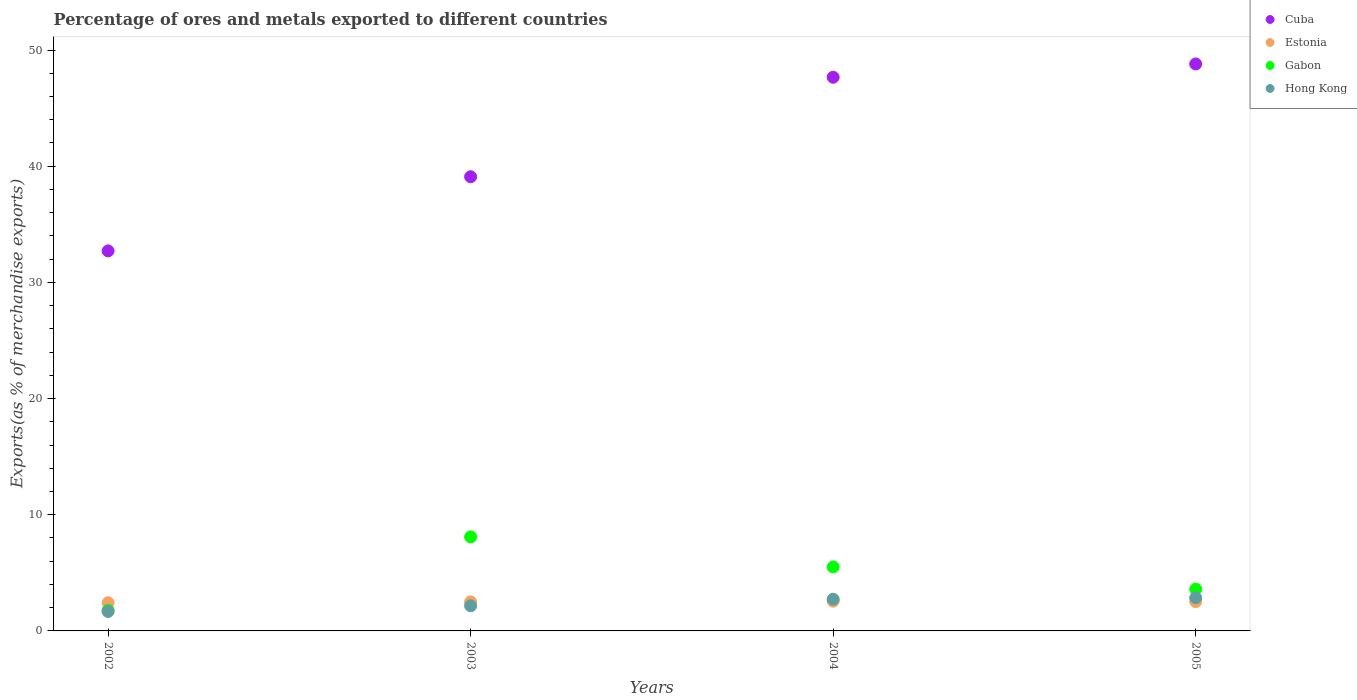How many different coloured dotlines are there?
Offer a terse response. 4. What is the percentage of exports to different countries in Gabon in 2002?
Your answer should be compact. 1.77. Across all years, what is the maximum percentage of exports to different countries in Estonia?
Provide a short and direct response. 2.56. Across all years, what is the minimum percentage of exports to different countries in Hong Kong?
Offer a very short reply. 1.67. In which year was the percentage of exports to different countries in Gabon maximum?
Provide a succinct answer. 2003. In which year was the percentage of exports to different countries in Cuba minimum?
Keep it short and to the point. 2002. What is the total percentage of exports to different countries in Cuba in the graph?
Provide a short and direct response. 168.26. What is the difference between the percentage of exports to different countries in Hong Kong in 2002 and that in 2005?
Make the answer very short. -1.18. What is the difference between the percentage of exports to different countries in Hong Kong in 2003 and the percentage of exports to different countries in Cuba in 2005?
Offer a terse response. -46.64. What is the average percentage of exports to different countries in Estonia per year?
Make the answer very short. 2.5. In the year 2004, what is the difference between the percentage of exports to different countries in Gabon and percentage of exports to different countries in Cuba?
Offer a very short reply. -42.15. In how many years, is the percentage of exports to different countries in Cuba greater than 12 %?
Give a very brief answer. 4. What is the ratio of the percentage of exports to different countries in Cuba in 2004 to that in 2005?
Make the answer very short. 0.98. Is the difference between the percentage of exports to different countries in Gabon in 2002 and 2005 greater than the difference between the percentage of exports to different countries in Cuba in 2002 and 2005?
Give a very brief answer. Yes. What is the difference between the highest and the second highest percentage of exports to different countries in Estonia?
Provide a succinct answer. 0.04. What is the difference between the highest and the lowest percentage of exports to different countries in Cuba?
Your answer should be compact. 16.09. Is the sum of the percentage of exports to different countries in Gabon in 2003 and 2004 greater than the maximum percentage of exports to different countries in Hong Kong across all years?
Keep it short and to the point. Yes. Are the values on the major ticks of Y-axis written in scientific E-notation?
Your answer should be compact. No. Does the graph contain grids?
Provide a succinct answer. No. Where does the legend appear in the graph?
Provide a succinct answer. Top right. How many legend labels are there?
Your answer should be very brief. 4. What is the title of the graph?
Your answer should be very brief. Percentage of ores and metals exported to different countries. What is the label or title of the X-axis?
Ensure brevity in your answer.  Years. What is the label or title of the Y-axis?
Ensure brevity in your answer.  Exports(as % of merchandise exports). What is the Exports(as % of merchandise exports) of Cuba in 2002?
Your answer should be compact. 32.71. What is the Exports(as % of merchandise exports) in Estonia in 2002?
Keep it short and to the point. 2.43. What is the Exports(as % of merchandise exports) of Gabon in 2002?
Offer a terse response. 1.77. What is the Exports(as % of merchandise exports) of Hong Kong in 2002?
Provide a succinct answer. 1.67. What is the Exports(as % of merchandise exports) in Cuba in 2003?
Offer a very short reply. 39.09. What is the Exports(as % of merchandise exports) of Estonia in 2003?
Keep it short and to the point. 2.5. What is the Exports(as % of merchandise exports) in Gabon in 2003?
Provide a succinct answer. 8.09. What is the Exports(as % of merchandise exports) in Hong Kong in 2003?
Provide a succinct answer. 2.16. What is the Exports(as % of merchandise exports) in Cuba in 2004?
Your answer should be compact. 47.66. What is the Exports(as % of merchandise exports) in Estonia in 2004?
Provide a succinct answer. 2.56. What is the Exports(as % of merchandise exports) of Gabon in 2004?
Ensure brevity in your answer.  5.51. What is the Exports(as % of merchandise exports) of Hong Kong in 2004?
Offer a very short reply. 2.73. What is the Exports(as % of merchandise exports) in Cuba in 2005?
Your response must be concise. 48.8. What is the Exports(as % of merchandise exports) of Estonia in 2005?
Provide a short and direct response. 2.52. What is the Exports(as % of merchandise exports) in Gabon in 2005?
Ensure brevity in your answer.  3.59. What is the Exports(as % of merchandise exports) in Hong Kong in 2005?
Your answer should be very brief. 2.85. Across all years, what is the maximum Exports(as % of merchandise exports) in Cuba?
Your response must be concise. 48.8. Across all years, what is the maximum Exports(as % of merchandise exports) in Estonia?
Offer a very short reply. 2.56. Across all years, what is the maximum Exports(as % of merchandise exports) in Gabon?
Offer a very short reply. 8.09. Across all years, what is the maximum Exports(as % of merchandise exports) of Hong Kong?
Offer a terse response. 2.85. Across all years, what is the minimum Exports(as % of merchandise exports) in Cuba?
Ensure brevity in your answer.  32.71. Across all years, what is the minimum Exports(as % of merchandise exports) in Estonia?
Your answer should be very brief. 2.43. Across all years, what is the minimum Exports(as % of merchandise exports) in Gabon?
Make the answer very short. 1.77. Across all years, what is the minimum Exports(as % of merchandise exports) in Hong Kong?
Give a very brief answer. 1.67. What is the total Exports(as % of merchandise exports) of Cuba in the graph?
Ensure brevity in your answer.  168.26. What is the total Exports(as % of merchandise exports) of Estonia in the graph?
Give a very brief answer. 10.01. What is the total Exports(as % of merchandise exports) of Gabon in the graph?
Your answer should be compact. 18.97. What is the total Exports(as % of merchandise exports) in Hong Kong in the graph?
Your answer should be compact. 9.42. What is the difference between the Exports(as % of merchandise exports) in Cuba in 2002 and that in 2003?
Offer a terse response. -6.38. What is the difference between the Exports(as % of merchandise exports) in Estonia in 2002 and that in 2003?
Make the answer very short. -0.07. What is the difference between the Exports(as % of merchandise exports) in Gabon in 2002 and that in 2003?
Make the answer very short. -6.32. What is the difference between the Exports(as % of merchandise exports) in Hong Kong in 2002 and that in 2003?
Offer a terse response. -0.49. What is the difference between the Exports(as % of merchandise exports) in Cuba in 2002 and that in 2004?
Ensure brevity in your answer.  -14.95. What is the difference between the Exports(as % of merchandise exports) in Estonia in 2002 and that in 2004?
Provide a short and direct response. -0.13. What is the difference between the Exports(as % of merchandise exports) of Gabon in 2002 and that in 2004?
Provide a short and direct response. -3.73. What is the difference between the Exports(as % of merchandise exports) of Hong Kong in 2002 and that in 2004?
Keep it short and to the point. -1.05. What is the difference between the Exports(as % of merchandise exports) in Cuba in 2002 and that in 2005?
Provide a succinct answer. -16.09. What is the difference between the Exports(as % of merchandise exports) of Estonia in 2002 and that in 2005?
Your response must be concise. -0.09. What is the difference between the Exports(as % of merchandise exports) of Gabon in 2002 and that in 2005?
Make the answer very short. -1.82. What is the difference between the Exports(as % of merchandise exports) of Hong Kong in 2002 and that in 2005?
Provide a short and direct response. -1.18. What is the difference between the Exports(as % of merchandise exports) in Cuba in 2003 and that in 2004?
Your answer should be compact. -8.56. What is the difference between the Exports(as % of merchandise exports) of Estonia in 2003 and that in 2004?
Provide a succinct answer. -0.06. What is the difference between the Exports(as % of merchandise exports) of Gabon in 2003 and that in 2004?
Keep it short and to the point. 2.59. What is the difference between the Exports(as % of merchandise exports) of Hong Kong in 2003 and that in 2004?
Give a very brief answer. -0.57. What is the difference between the Exports(as % of merchandise exports) in Cuba in 2003 and that in 2005?
Make the answer very short. -9.71. What is the difference between the Exports(as % of merchandise exports) in Estonia in 2003 and that in 2005?
Offer a terse response. -0.02. What is the difference between the Exports(as % of merchandise exports) of Gabon in 2003 and that in 2005?
Provide a short and direct response. 4.5. What is the difference between the Exports(as % of merchandise exports) in Hong Kong in 2003 and that in 2005?
Your answer should be very brief. -0.69. What is the difference between the Exports(as % of merchandise exports) in Cuba in 2004 and that in 2005?
Keep it short and to the point. -1.15. What is the difference between the Exports(as % of merchandise exports) in Estonia in 2004 and that in 2005?
Your answer should be compact. 0.04. What is the difference between the Exports(as % of merchandise exports) in Gabon in 2004 and that in 2005?
Ensure brevity in your answer.  1.92. What is the difference between the Exports(as % of merchandise exports) in Hong Kong in 2004 and that in 2005?
Offer a terse response. -0.12. What is the difference between the Exports(as % of merchandise exports) in Cuba in 2002 and the Exports(as % of merchandise exports) in Estonia in 2003?
Provide a short and direct response. 30.21. What is the difference between the Exports(as % of merchandise exports) of Cuba in 2002 and the Exports(as % of merchandise exports) of Gabon in 2003?
Your response must be concise. 24.62. What is the difference between the Exports(as % of merchandise exports) of Cuba in 2002 and the Exports(as % of merchandise exports) of Hong Kong in 2003?
Offer a very short reply. 30.55. What is the difference between the Exports(as % of merchandise exports) in Estonia in 2002 and the Exports(as % of merchandise exports) in Gabon in 2003?
Your answer should be very brief. -5.67. What is the difference between the Exports(as % of merchandise exports) in Estonia in 2002 and the Exports(as % of merchandise exports) in Hong Kong in 2003?
Keep it short and to the point. 0.27. What is the difference between the Exports(as % of merchandise exports) in Gabon in 2002 and the Exports(as % of merchandise exports) in Hong Kong in 2003?
Keep it short and to the point. -0.39. What is the difference between the Exports(as % of merchandise exports) in Cuba in 2002 and the Exports(as % of merchandise exports) in Estonia in 2004?
Provide a succinct answer. 30.15. What is the difference between the Exports(as % of merchandise exports) of Cuba in 2002 and the Exports(as % of merchandise exports) of Gabon in 2004?
Your answer should be compact. 27.2. What is the difference between the Exports(as % of merchandise exports) of Cuba in 2002 and the Exports(as % of merchandise exports) of Hong Kong in 2004?
Make the answer very short. 29.98. What is the difference between the Exports(as % of merchandise exports) of Estonia in 2002 and the Exports(as % of merchandise exports) of Gabon in 2004?
Provide a short and direct response. -3.08. What is the difference between the Exports(as % of merchandise exports) in Estonia in 2002 and the Exports(as % of merchandise exports) in Hong Kong in 2004?
Provide a short and direct response. -0.3. What is the difference between the Exports(as % of merchandise exports) in Gabon in 2002 and the Exports(as % of merchandise exports) in Hong Kong in 2004?
Make the answer very short. -0.95. What is the difference between the Exports(as % of merchandise exports) of Cuba in 2002 and the Exports(as % of merchandise exports) of Estonia in 2005?
Your answer should be very brief. 30.19. What is the difference between the Exports(as % of merchandise exports) in Cuba in 2002 and the Exports(as % of merchandise exports) in Gabon in 2005?
Your answer should be very brief. 29.12. What is the difference between the Exports(as % of merchandise exports) in Cuba in 2002 and the Exports(as % of merchandise exports) in Hong Kong in 2005?
Offer a very short reply. 29.86. What is the difference between the Exports(as % of merchandise exports) in Estonia in 2002 and the Exports(as % of merchandise exports) in Gabon in 2005?
Your answer should be very brief. -1.17. What is the difference between the Exports(as % of merchandise exports) of Estonia in 2002 and the Exports(as % of merchandise exports) of Hong Kong in 2005?
Provide a succinct answer. -0.43. What is the difference between the Exports(as % of merchandise exports) of Gabon in 2002 and the Exports(as % of merchandise exports) of Hong Kong in 2005?
Ensure brevity in your answer.  -1.08. What is the difference between the Exports(as % of merchandise exports) of Cuba in 2003 and the Exports(as % of merchandise exports) of Estonia in 2004?
Your response must be concise. 36.53. What is the difference between the Exports(as % of merchandise exports) of Cuba in 2003 and the Exports(as % of merchandise exports) of Gabon in 2004?
Your answer should be very brief. 33.58. What is the difference between the Exports(as % of merchandise exports) in Cuba in 2003 and the Exports(as % of merchandise exports) in Hong Kong in 2004?
Make the answer very short. 36.36. What is the difference between the Exports(as % of merchandise exports) in Estonia in 2003 and the Exports(as % of merchandise exports) in Gabon in 2004?
Your answer should be compact. -3.01. What is the difference between the Exports(as % of merchandise exports) in Estonia in 2003 and the Exports(as % of merchandise exports) in Hong Kong in 2004?
Make the answer very short. -0.23. What is the difference between the Exports(as % of merchandise exports) in Gabon in 2003 and the Exports(as % of merchandise exports) in Hong Kong in 2004?
Your answer should be compact. 5.37. What is the difference between the Exports(as % of merchandise exports) in Cuba in 2003 and the Exports(as % of merchandise exports) in Estonia in 2005?
Keep it short and to the point. 36.57. What is the difference between the Exports(as % of merchandise exports) in Cuba in 2003 and the Exports(as % of merchandise exports) in Gabon in 2005?
Offer a terse response. 35.5. What is the difference between the Exports(as % of merchandise exports) in Cuba in 2003 and the Exports(as % of merchandise exports) in Hong Kong in 2005?
Provide a short and direct response. 36.24. What is the difference between the Exports(as % of merchandise exports) of Estonia in 2003 and the Exports(as % of merchandise exports) of Gabon in 2005?
Your answer should be compact. -1.09. What is the difference between the Exports(as % of merchandise exports) of Estonia in 2003 and the Exports(as % of merchandise exports) of Hong Kong in 2005?
Your response must be concise. -0.35. What is the difference between the Exports(as % of merchandise exports) of Gabon in 2003 and the Exports(as % of merchandise exports) of Hong Kong in 2005?
Give a very brief answer. 5.24. What is the difference between the Exports(as % of merchandise exports) in Cuba in 2004 and the Exports(as % of merchandise exports) in Estonia in 2005?
Make the answer very short. 45.13. What is the difference between the Exports(as % of merchandise exports) in Cuba in 2004 and the Exports(as % of merchandise exports) in Gabon in 2005?
Ensure brevity in your answer.  44.06. What is the difference between the Exports(as % of merchandise exports) of Cuba in 2004 and the Exports(as % of merchandise exports) of Hong Kong in 2005?
Your response must be concise. 44.8. What is the difference between the Exports(as % of merchandise exports) in Estonia in 2004 and the Exports(as % of merchandise exports) in Gabon in 2005?
Offer a very short reply. -1.03. What is the difference between the Exports(as % of merchandise exports) in Estonia in 2004 and the Exports(as % of merchandise exports) in Hong Kong in 2005?
Keep it short and to the point. -0.29. What is the difference between the Exports(as % of merchandise exports) in Gabon in 2004 and the Exports(as % of merchandise exports) in Hong Kong in 2005?
Offer a very short reply. 2.66. What is the average Exports(as % of merchandise exports) in Cuba per year?
Offer a very short reply. 42.06. What is the average Exports(as % of merchandise exports) of Estonia per year?
Offer a very short reply. 2.5. What is the average Exports(as % of merchandise exports) in Gabon per year?
Offer a terse response. 4.74. What is the average Exports(as % of merchandise exports) of Hong Kong per year?
Your response must be concise. 2.35. In the year 2002, what is the difference between the Exports(as % of merchandise exports) of Cuba and Exports(as % of merchandise exports) of Estonia?
Provide a succinct answer. 30.28. In the year 2002, what is the difference between the Exports(as % of merchandise exports) of Cuba and Exports(as % of merchandise exports) of Gabon?
Offer a very short reply. 30.94. In the year 2002, what is the difference between the Exports(as % of merchandise exports) in Cuba and Exports(as % of merchandise exports) in Hong Kong?
Keep it short and to the point. 31.03. In the year 2002, what is the difference between the Exports(as % of merchandise exports) of Estonia and Exports(as % of merchandise exports) of Gabon?
Provide a short and direct response. 0.65. In the year 2002, what is the difference between the Exports(as % of merchandise exports) in Estonia and Exports(as % of merchandise exports) in Hong Kong?
Ensure brevity in your answer.  0.75. In the year 2002, what is the difference between the Exports(as % of merchandise exports) in Gabon and Exports(as % of merchandise exports) in Hong Kong?
Offer a very short reply. 0.1. In the year 2003, what is the difference between the Exports(as % of merchandise exports) of Cuba and Exports(as % of merchandise exports) of Estonia?
Provide a short and direct response. 36.59. In the year 2003, what is the difference between the Exports(as % of merchandise exports) in Cuba and Exports(as % of merchandise exports) in Gabon?
Your answer should be very brief. 31. In the year 2003, what is the difference between the Exports(as % of merchandise exports) of Cuba and Exports(as % of merchandise exports) of Hong Kong?
Provide a short and direct response. 36.93. In the year 2003, what is the difference between the Exports(as % of merchandise exports) in Estonia and Exports(as % of merchandise exports) in Gabon?
Your answer should be compact. -5.59. In the year 2003, what is the difference between the Exports(as % of merchandise exports) of Estonia and Exports(as % of merchandise exports) of Hong Kong?
Keep it short and to the point. 0.34. In the year 2003, what is the difference between the Exports(as % of merchandise exports) of Gabon and Exports(as % of merchandise exports) of Hong Kong?
Make the answer very short. 5.93. In the year 2004, what is the difference between the Exports(as % of merchandise exports) in Cuba and Exports(as % of merchandise exports) in Estonia?
Make the answer very short. 45.09. In the year 2004, what is the difference between the Exports(as % of merchandise exports) in Cuba and Exports(as % of merchandise exports) in Gabon?
Keep it short and to the point. 42.15. In the year 2004, what is the difference between the Exports(as % of merchandise exports) of Cuba and Exports(as % of merchandise exports) of Hong Kong?
Your answer should be very brief. 44.93. In the year 2004, what is the difference between the Exports(as % of merchandise exports) in Estonia and Exports(as % of merchandise exports) in Gabon?
Provide a succinct answer. -2.95. In the year 2004, what is the difference between the Exports(as % of merchandise exports) of Estonia and Exports(as % of merchandise exports) of Hong Kong?
Offer a terse response. -0.17. In the year 2004, what is the difference between the Exports(as % of merchandise exports) in Gabon and Exports(as % of merchandise exports) in Hong Kong?
Your answer should be very brief. 2.78. In the year 2005, what is the difference between the Exports(as % of merchandise exports) in Cuba and Exports(as % of merchandise exports) in Estonia?
Your response must be concise. 46.28. In the year 2005, what is the difference between the Exports(as % of merchandise exports) in Cuba and Exports(as % of merchandise exports) in Gabon?
Ensure brevity in your answer.  45.21. In the year 2005, what is the difference between the Exports(as % of merchandise exports) of Cuba and Exports(as % of merchandise exports) of Hong Kong?
Your answer should be very brief. 45.95. In the year 2005, what is the difference between the Exports(as % of merchandise exports) in Estonia and Exports(as % of merchandise exports) in Gabon?
Provide a succinct answer. -1.07. In the year 2005, what is the difference between the Exports(as % of merchandise exports) in Estonia and Exports(as % of merchandise exports) in Hong Kong?
Your answer should be compact. -0.33. In the year 2005, what is the difference between the Exports(as % of merchandise exports) in Gabon and Exports(as % of merchandise exports) in Hong Kong?
Offer a terse response. 0.74. What is the ratio of the Exports(as % of merchandise exports) in Cuba in 2002 to that in 2003?
Your answer should be very brief. 0.84. What is the ratio of the Exports(as % of merchandise exports) in Estonia in 2002 to that in 2003?
Give a very brief answer. 0.97. What is the ratio of the Exports(as % of merchandise exports) of Gabon in 2002 to that in 2003?
Make the answer very short. 0.22. What is the ratio of the Exports(as % of merchandise exports) in Hong Kong in 2002 to that in 2003?
Give a very brief answer. 0.77. What is the ratio of the Exports(as % of merchandise exports) in Cuba in 2002 to that in 2004?
Make the answer very short. 0.69. What is the ratio of the Exports(as % of merchandise exports) of Estonia in 2002 to that in 2004?
Give a very brief answer. 0.95. What is the ratio of the Exports(as % of merchandise exports) of Gabon in 2002 to that in 2004?
Provide a succinct answer. 0.32. What is the ratio of the Exports(as % of merchandise exports) of Hong Kong in 2002 to that in 2004?
Your answer should be very brief. 0.61. What is the ratio of the Exports(as % of merchandise exports) of Cuba in 2002 to that in 2005?
Provide a short and direct response. 0.67. What is the ratio of the Exports(as % of merchandise exports) of Estonia in 2002 to that in 2005?
Provide a succinct answer. 0.96. What is the ratio of the Exports(as % of merchandise exports) in Gabon in 2002 to that in 2005?
Keep it short and to the point. 0.49. What is the ratio of the Exports(as % of merchandise exports) in Hong Kong in 2002 to that in 2005?
Ensure brevity in your answer.  0.59. What is the ratio of the Exports(as % of merchandise exports) of Cuba in 2003 to that in 2004?
Give a very brief answer. 0.82. What is the ratio of the Exports(as % of merchandise exports) in Estonia in 2003 to that in 2004?
Provide a succinct answer. 0.98. What is the ratio of the Exports(as % of merchandise exports) in Gabon in 2003 to that in 2004?
Ensure brevity in your answer.  1.47. What is the ratio of the Exports(as % of merchandise exports) in Hong Kong in 2003 to that in 2004?
Offer a terse response. 0.79. What is the ratio of the Exports(as % of merchandise exports) in Cuba in 2003 to that in 2005?
Offer a very short reply. 0.8. What is the ratio of the Exports(as % of merchandise exports) in Gabon in 2003 to that in 2005?
Make the answer very short. 2.25. What is the ratio of the Exports(as % of merchandise exports) of Hong Kong in 2003 to that in 2005?
Give a very brief answer. 0.76. What is the ratio of the Exports(as % of merchandise exports) of Cuba in 2004 to that in 2005?
Offer a terse response. 0.98. What is the ratio of the Exports(as % of merchandise exports) of Estonia in 2004 to that in 2005?
Keep it short and to the point. 1.02. What is the ratio of the Exports(as % of merchandise exports) in Gabon in 2004 to that in 2005?
Your answer should be very brief. 1.53. What is the ratio of the Exports(as % of merchandise exports) of Hong Kong in 2004 to that in 2005?
Provide a succinct answer. 0.96. What is the difference between the highest and the second highest Exports(as % of merchandise exports) in Cuba?
Keep it short and to the point. 1.15. What is the difference between the highest and the second highest Exports(as % of merchandise exports) in Estonia?
Offer a terse response. 0.04. What is the difference between the highest and the second highest Exports(as % of merchandise exports) in Gabon?
Keep it short and to the point. 2.59. What is the difference between the highest and the second highest Exports(as % of merchandise exports) in Hong Kong?
Make the answer very short. 0.12. What is the difference between the highest and the lowest Exports(as % of merchandise exports) in Cuba?
Offer a terse response. 16.09. What is the difference between the highest and the lowest Exports(as % of merchandise exports) in Estonia?
Keep it short and to the point. 0.13. What is the difference between the highest and the lowest Exports(as % of merchandise exports) in Gabon?
Offer a very short reply. 6.32. What is the difference between the highest and the lowest Exports(as % of merchandise exports) in Hong Kong?
Make the answer very short. 1.18. 